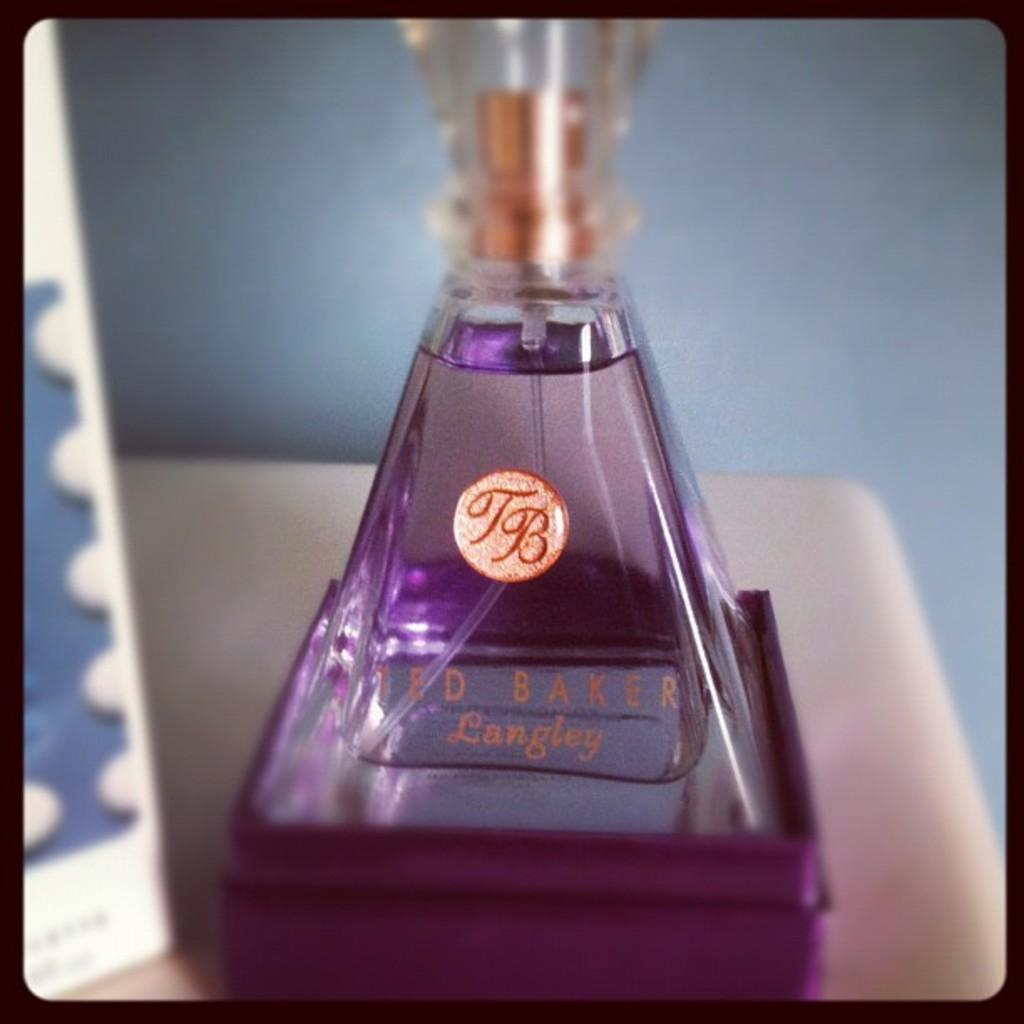<image>
Present a compact description of the photo's key features. A product from Ted Baker Langley is in a pyramid shaped container. 